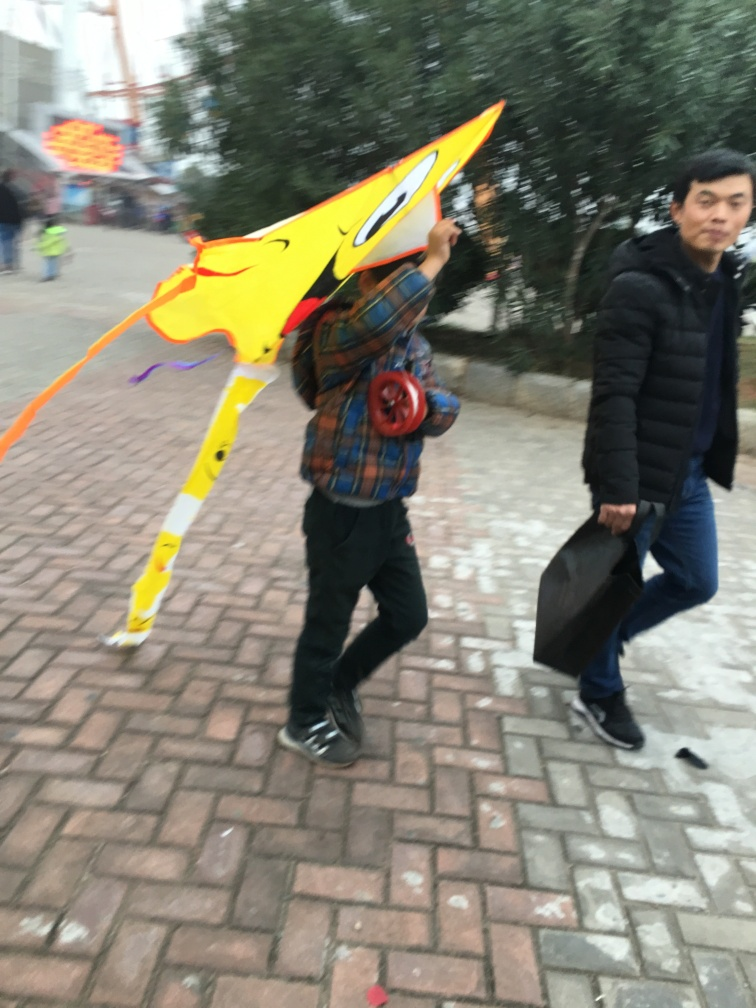What might the person be carrying and for what purpose? The individual appears to be carrying a large, colorful kite. It is likely they are on their way to an open area to fly it, as kites need space and wind to soar. 